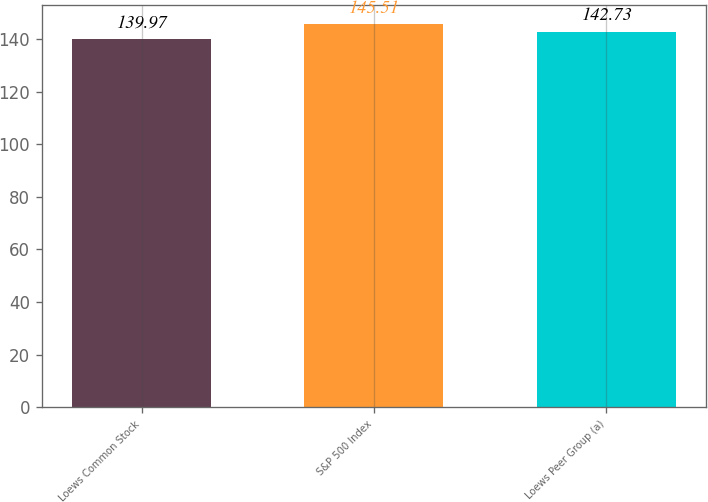Convert chart. <chart><loc_0><loc_0><loc_500><loc_500><bar_chart><fcel>Loews Common Stock<fcel>S&P 500 Index<fcel>Loews Peer Group (a)<nl><fcel>139.97<fcel>145.51<fcel>142.73<nl></chart> 